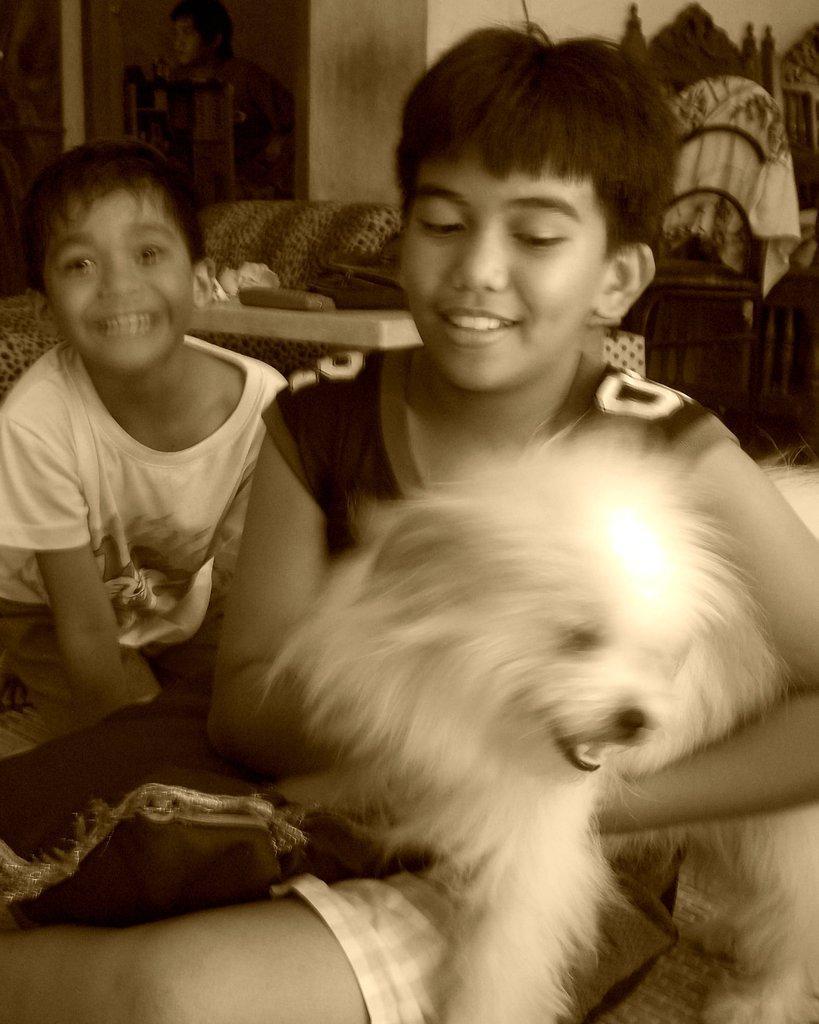How would you summarize this image in a sentence or two? In this image, there are two boys sitting on the bed and holding a dog of white in color and having a smile on their face. In the background to, a wall painting is visible and a wall of white in color. This image is taken inside a room. 